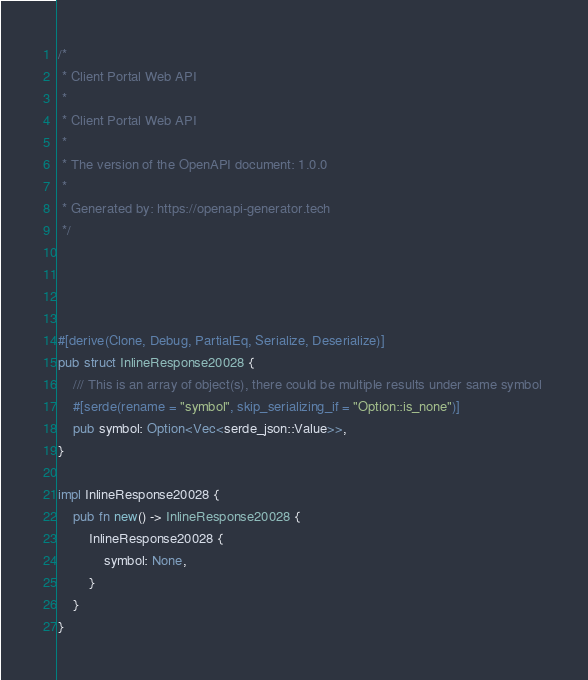<code> <loc_0><loc_0><loc_500><loc_500><_Rust_>/*
 * Client Portal Web API
 *
 * Client Portal Web API
 *
 * The version of the OpenAPI document: 1.0.0
 * 
 * Generated by: https://openapi-generator.tech
 */




#[derive(Clone, Debug, PartialEq, Serialize, Deserialize)]
pub struct InlineResponse20028 {
    /// This is an array of object(s), there could be multiple results under same symbol 
    #[serde(rename = "symbol", skip_serializing_if = "Option::is_none")]
    pub symbol: Option<Vec<serde_json::Value>>,
}

impl InlineResponse20028 {
    pub fn new() -> InlineResponse20028 {
        InlineResponse20028 {
            symbol: None,
        }
    }
}


</code> 